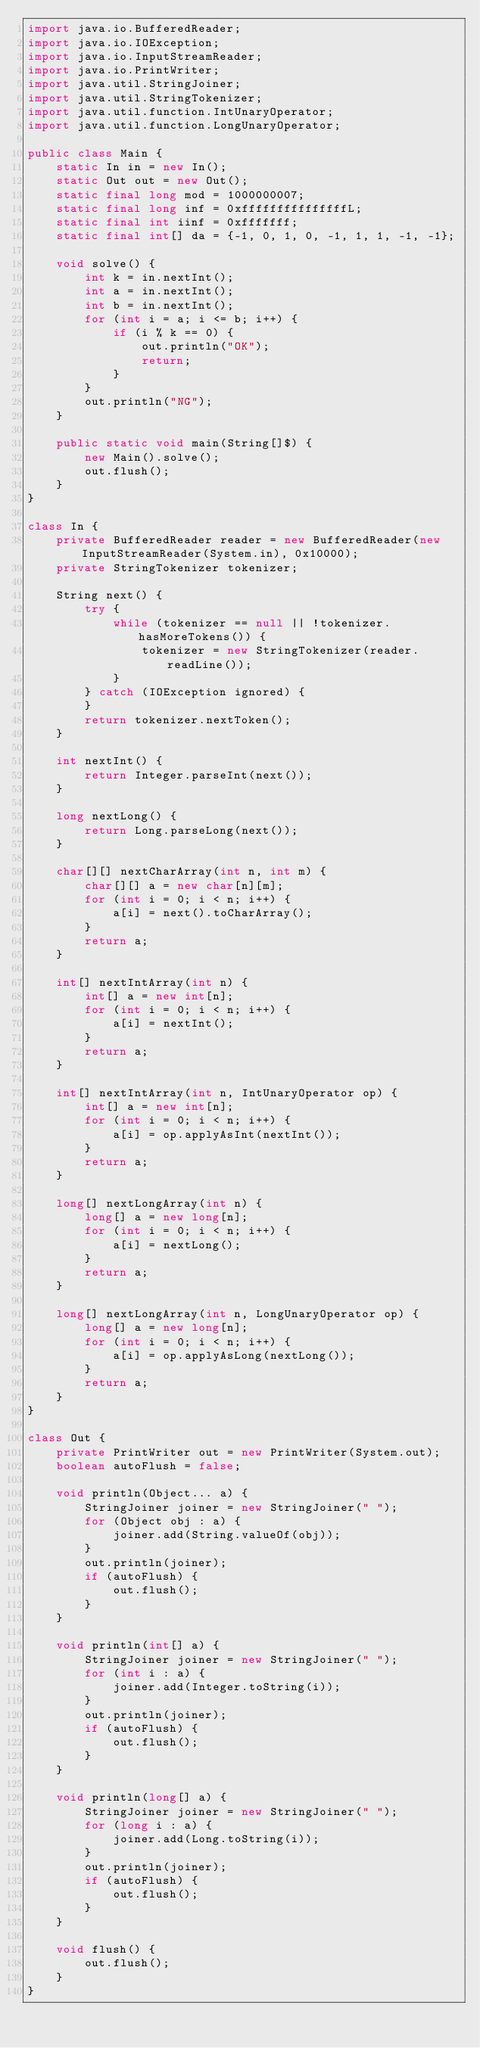<code> <loc_0><loc_0><loc_500><loc_500><_Java_>import java.io.BufferedReader;
import java.io.IOException;
import java.io.InputStreamReader;
import java.io.PrintWriter;
import java.util.StringJoiner;
import java.util.StringTokenizer;
import java.util.function.IntUnaryOperator;
import java.util.function.LongUnaryOperator;

public class Main {
    static In in = new In();
    static Out out = new Out();
    static final long mod = 1000000007;
    static final long inf = 0xfffffffffffffffL;
    static final int iinf = 0xfffffff;
    static final int[] da = {-1, 0, 1, 0, -1, 1, 1, -1, -1};

    void solve() {
        int k = in.nextInt();
        int a = in.nextInt();
        int b = in.nextInt();
        for (int i = a; i <= b; i++) {
            if (i % k == 0) {
                out.println("OK");
                return;
            }
        }
        out.println("NG");
    }

    public static void main(String[]$) {
        new Main().solve();
        out.flush();
    }
}

class In {
    private BufferedReader reader = new BufferedReader(new InputStreamReader(System.in), 0x10000);
    private StringTokenizer tokenizer;

    String next() {
        try {
            while (tokenizer == null || !tokenizer.hasMoreTokens()) {
                tokenizer = new StringTokenizer(reader.readLine());
            }
        } catch (IOException ignored) {
        }
        return tokenizer.nextToken();
    }

    int nextInt() {
        return Integer.parseInt(next());
    }

    long nextLong() {
        return Long.parseLong(next());
    }

    char[][] nextCharArray(int n, int m) {
        char[][] a = new char[n][m];
        for (int i = 0; i < n; i++) {
            a[i] = next().toCharArray();
        }
        return a;
    }

    int[] nextIntArray(int n) {
        int[] a = new int[n];
        for (int i = 0; i < n; i++) {
            a[i] = nextInt();
        }
        return a;
    }

    int[] nextIntArray(int n, IntUnaryOperator op) {
        int[] a = new int[n];
        for (int i = 0; i < n; i++) {
            a[i] = op.applyAsInt(nextInt());
        }
        return a;
    }

    long[] nextLongArray(int n) {
        long[] a = new long[n];
        for (int i = 0; i < n; i++) {
            a[i] = nextLong();
        }
        return a;
    }

    long[] nextLongArray(int n, LongUnaryOperator op) {
        long[] a = new long[n];
        for (int i = 0; i < n; i++) {
            a[i] = op.applyAsLong(nextLong());
        }
        return a;
    }
}

class Out {
    private PrintWriter out = new PrintWriter(System.out);
    boolean autoFlush = false;

    void println(Object... a) {
        StringJoiner joiner = new StringJoiner(" ");
        for (Object obj : a) {
            joiner.add(String.valueOf(obj));
        }
        out.println(joiner);
        if (autoFlush) {
            out.flush();
        }
    }

    void println(int[] a) {
        StringJoiner joiner = new StringJoiner(" ");
        for (int i : a) {
            joiner.add(Integer.toString(i));
        }
        out.println(joiner);
        if (autoFlush) {
            out.flush();
        }
    }

    void println(long[] a) {
        StringJoiner joiner = new StringJoiner(" ");
        for (long i : a) {
            joiner.add(Long.toString(i));
        }
        out.println(joiner);
        if (autoFlush) {
            out.flush();
        }
    }

    void flush() {
        out.flush();
    }
}
</code> 